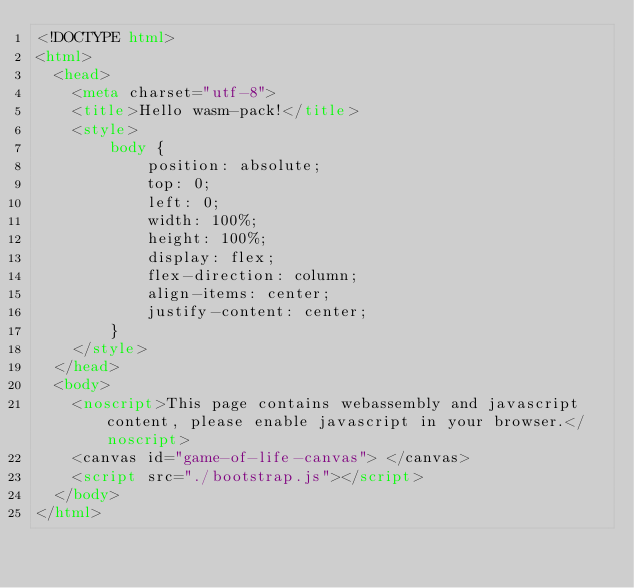Convert code to text. <code><loc_0><loc_0><loc_500><loc_500><_HTML_><!DOCTYPE html>
<html>
  <head>
    <meta charset="utf-8">
    <title>Hello wasm-pack!</title>
    <style>
        body {
            position: absolute;
            top: 0;
            left: 0;
            width: 100%;
            height: 100%;
            display: flex;
            flex-direction: column;
            align-items: center;
            justify-content: center;
        }
    </style>
  </head>
  <body>
    <noscript>This page contains webassembly and javascript content, please enable javascript in your browser.</noscript>
    <canvas id="game-of-life-canvas"> </canvas>
    <script src="./bootstrap.js"></script>
  </body>
</html>
</code> 